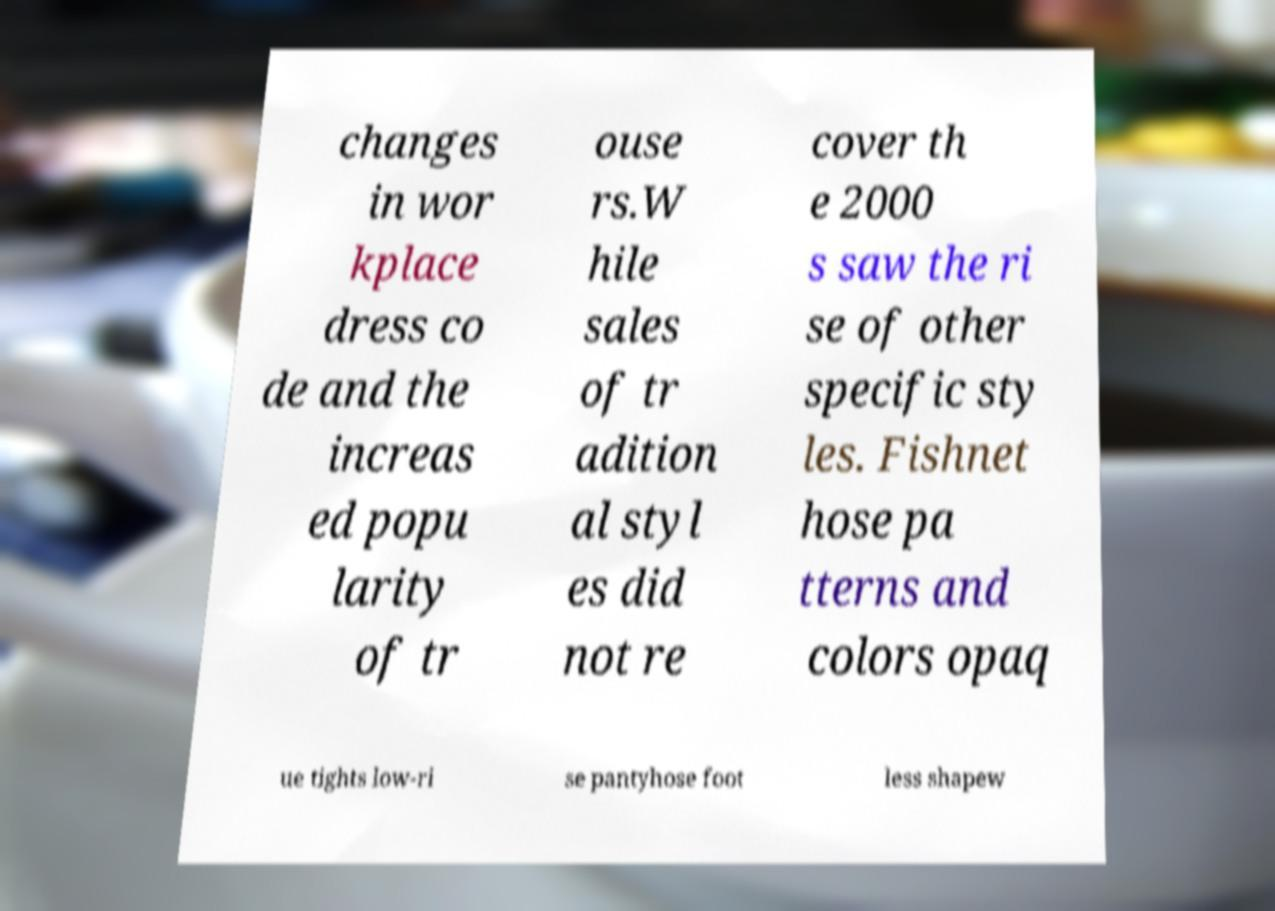I need the written content from this picture converted into text. Can you do that? changes in wor kplace dress co de and the increas ed popu larity of tr ouse rs.W hile sales of tr adition al styl es did not re cover th e 2000 s saw the ri se of other specific sty les. Fishnet hose pa tterns and colors opaq ue tights low-ri se pantyhose foot less shapew 